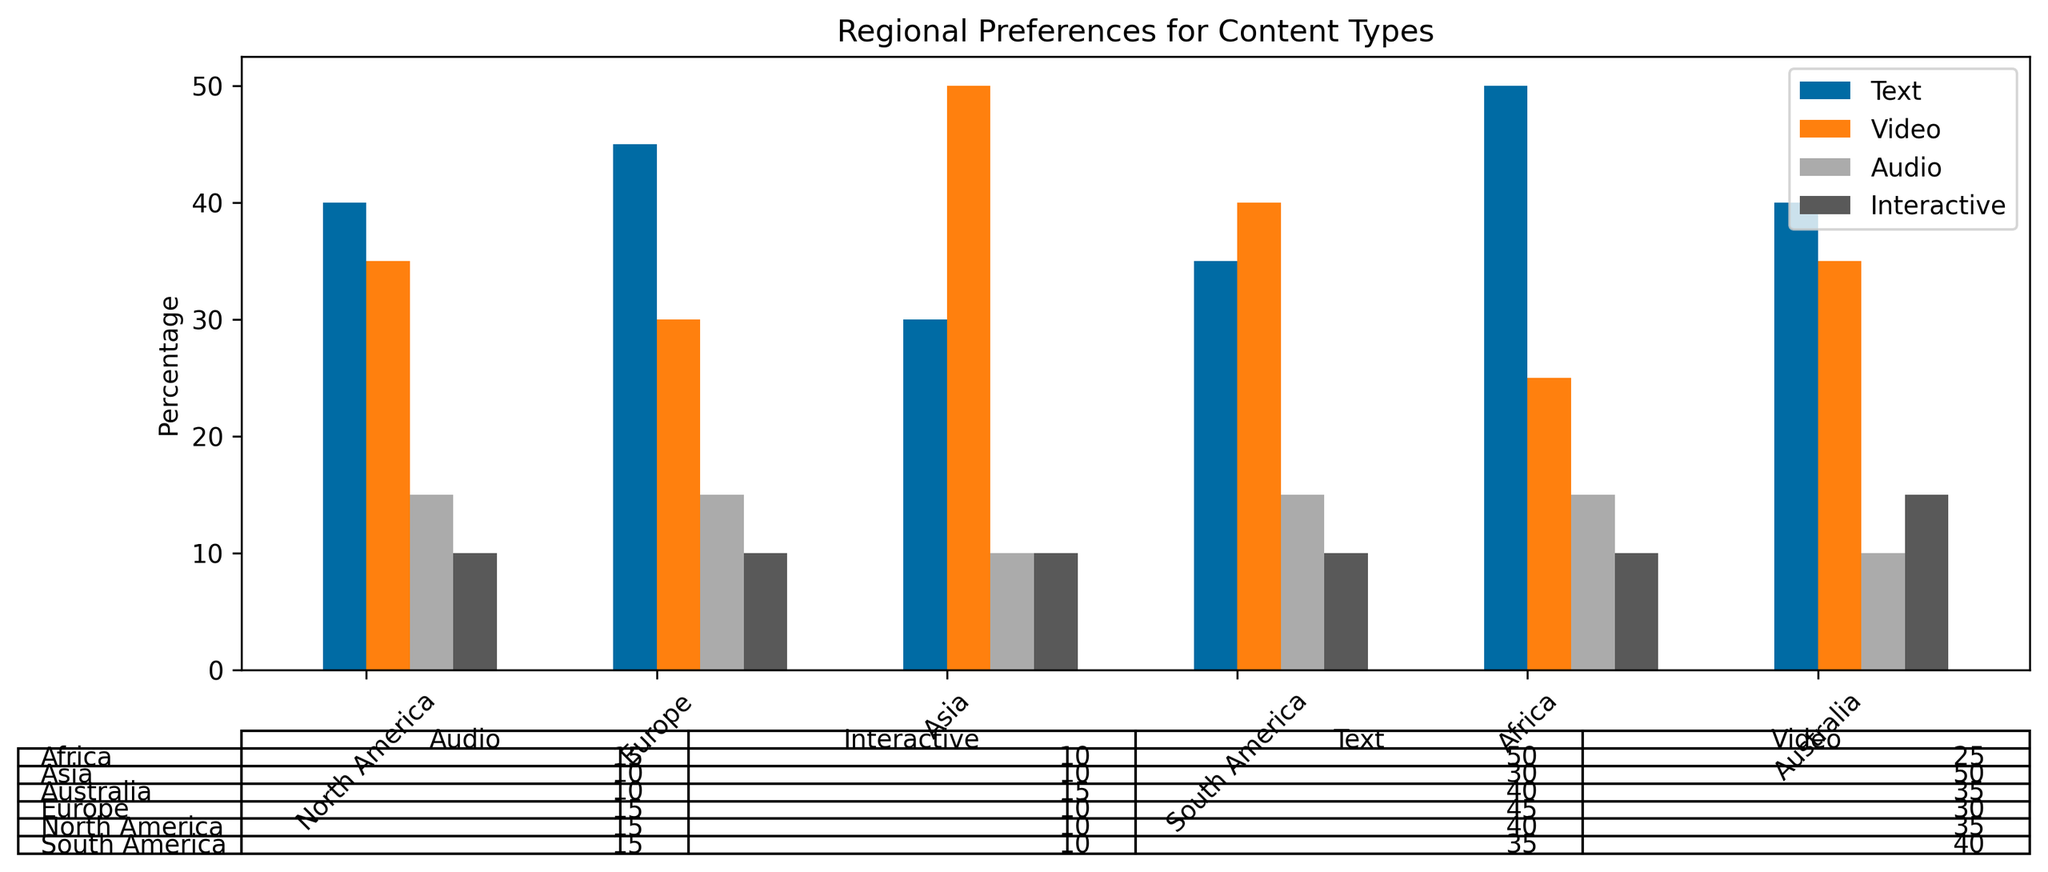Which region has the highest preference for video content? Looking at the heights of the bars for the 'Video' category, Asia has the tallest bar followed by South America, Australia, North America, Europe, and Africa.
Answer: Asia Which type of content is preferred equally in all the regions? By looking at the bars of the same height across regions, the 'Interactive' content type has bars of equal height (10%) in each region.
Answer: Interactive Which region has the lowest preference for text content? By comparing the heights of the 'Text' bars across regions, Asia has the shortest bar at 30%.
Answer: Asia What is the difference in the percentage preference for audio content between North America and Asia? The percentage for audio in North America is 15%, and in Asia, it is 10%. The difference is 15 - 10 = 5%.
Answer: 5% Which two regions have the same preference percentage for audio content? By examining the bars of the 'Audio' category, North America, Europe, and South America all show audio preferences at 15%.
Answer: North America, Europe, and South America What is the combined percentage of preferences for text and video content in Europe? The preference for text in Europe is 45% and for video, it is 30%. The combined percentage is 45 + 30 = 75%.
Answer: 75% In which region is the gap between text and video content preference the smallest? By comparing the differences between text and video percentages in each region: North America (40-35=5), Europe (45-30=15), Asia (50-30=20), South America (40-35=5), Africa (25-50=25), and Australia (35-40=5), the smallest gap is in North America, South America, and Australia, each with a difference of 5%.
Answer: North America, South America, Australia Which region shows an equal preference for text and video content? By comparing the heights of the bars for 'Text' and 'Video' categories, no region shows equal heights for these two content types.
Answer: None 